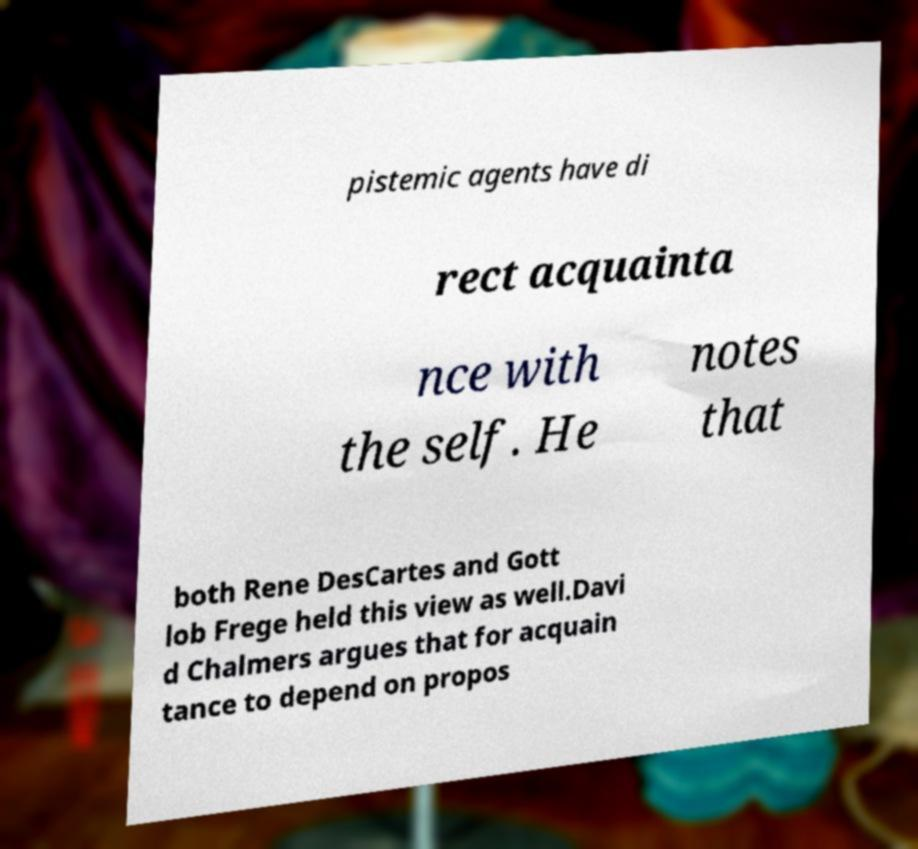For documentation purposes, I need the text within this image transcribed. Could you provide that? pistemic agents have di rect acquainta nce with the self. He notes that both Rene DesCartes and Gott lob Frege held this view as well.Davi d Chalmers argues that for acquain tance to depend on propos 